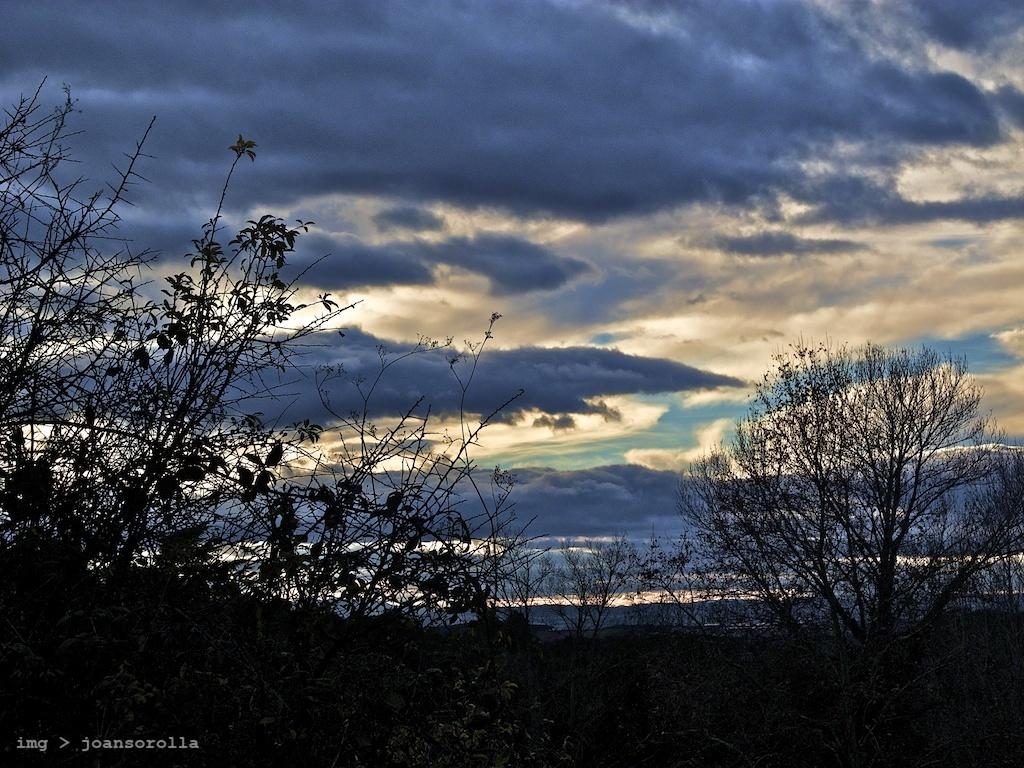What type of vegetation is present in the image? There are trees with branches and leaves in the image. What can be seen in the sky in the image? There are clouds in the sky in the image. Is there any text or marking at the bottom of the image? Yes, there is a watermark at the bottom of the image. What type of stew is being prepared in the image? There is no stew present in the image; it features trees, clouds, and a watermark. What type of destruction can be seen in the image? There is no destruction present in the image; it features a peaceful scene with trees and clouds. 